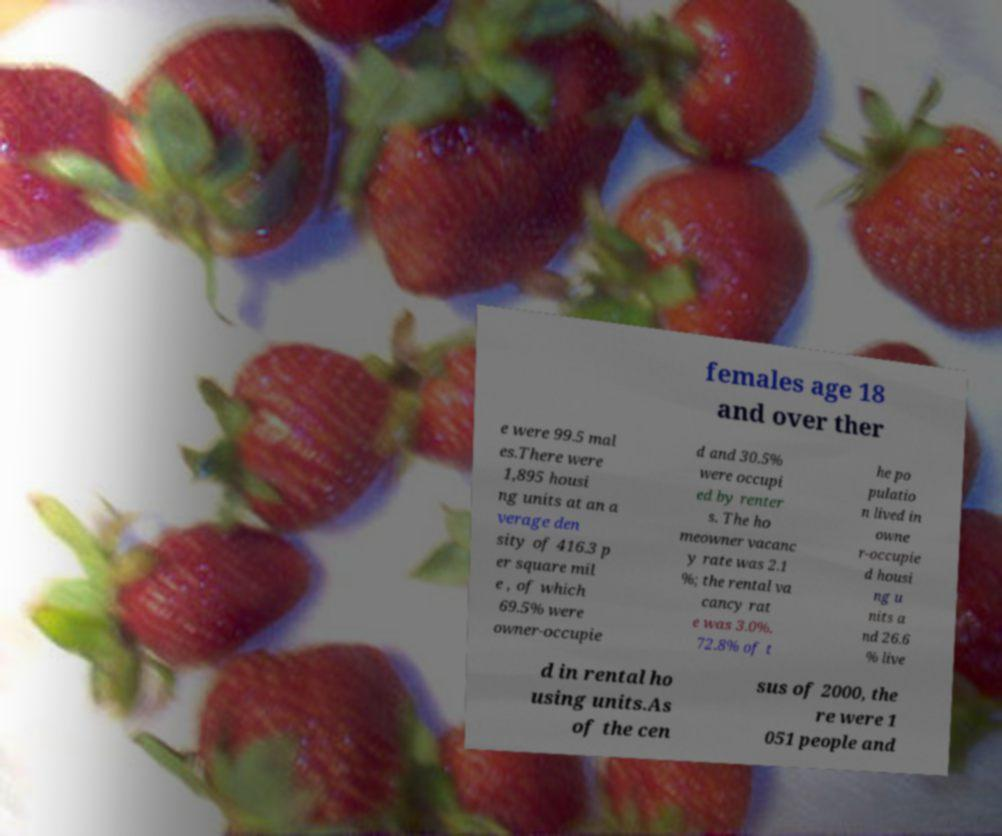For documentation purposes, I need the text within this image transcribed. Could you provide that? females age 18 and over ther e were 99.5 mal es.There were 1,895 housi ng units at an a verage den sity of 416.3 p er square mil e , of which 69.5% were owner-occupie d and 30.5% were occupi ed by renter s. The ho meowner vacanc y rate was 2.1 %; the rental va cancy rat e was 3.0%. 72.8% of t he po pulatio n lived in owne r-occupie d housi ng u nits a nd 26.6 % live d in rental ho using units.As of the cen sus of 2000, the re were 1 051 people and 